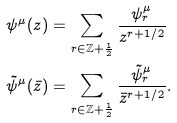<formula> <loc_0><loc_0><loc_500><loc_500>\psi ^ { \mu } ( z ) & = \sum _ { r \in \mathbb { Z } + \frac { 1 } { 2 } } \frac { \psi _ { r } ^ { \mu } } { z ^ { r + 1 / 2 } } \\ \tilde { \psi } ^ { \mu } ( \bar { z } ) & = \sum _ { r \in \mathbb { Z } + \frac { 1 } { 2 } } \frac { \tilde { \psi } _ { r } ^ { \mu } } { \bar { z } ^ { r + 1 / 2 } } .</formula> 